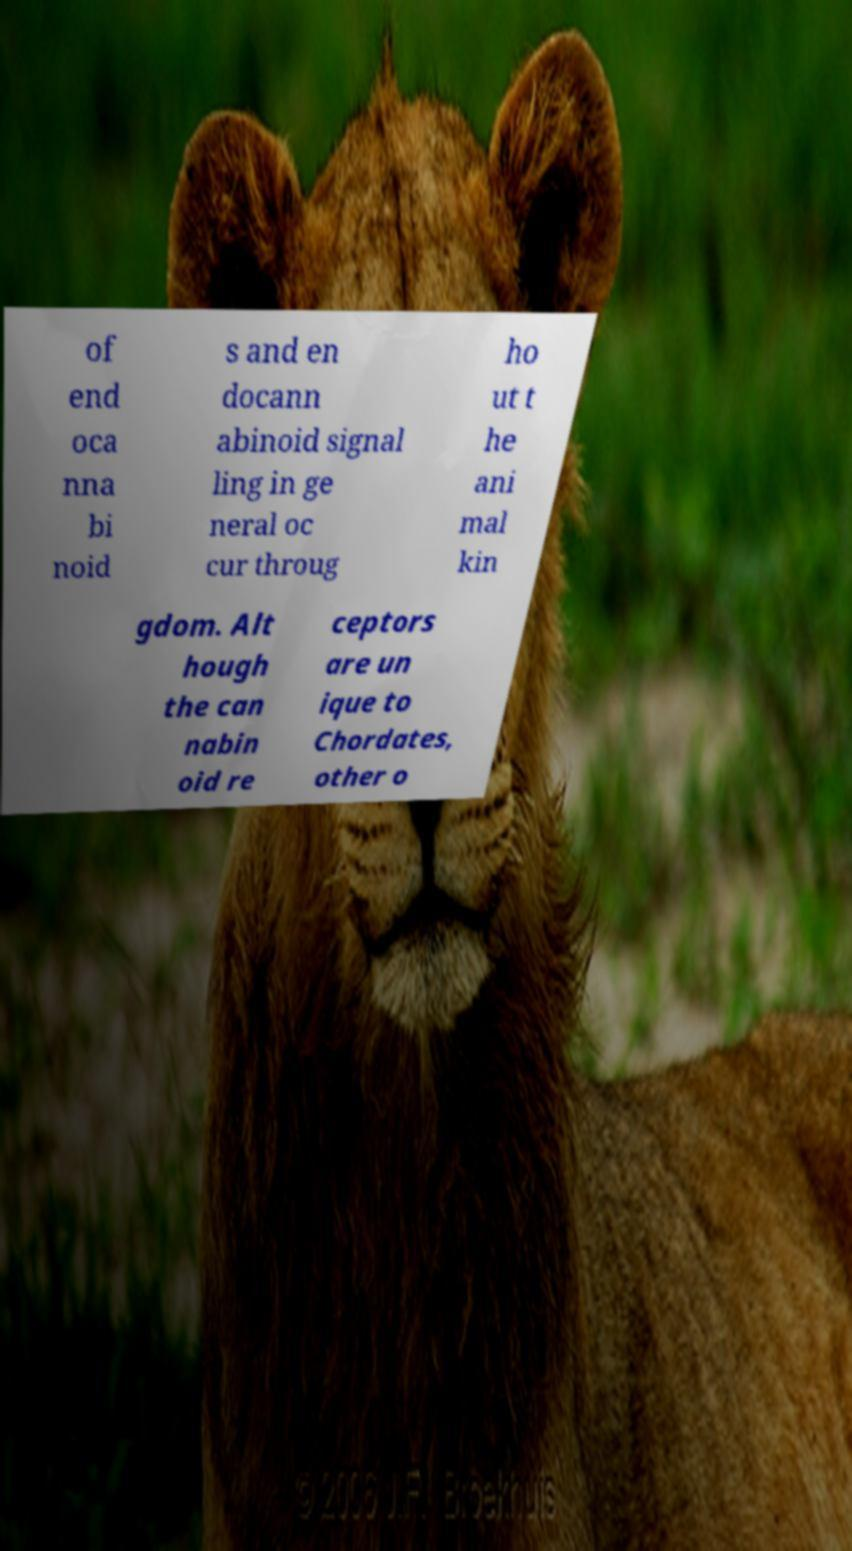What messages or text are displayed in this image? I need them in a readable, typed format. of end oca nna bi noid s and en docann abinoid signal ling in ge neral oc cur throug ho ut t he ani mal kin gdom. Alt hough the can nabin oid re ceptors are un ique to Chordates, other o 